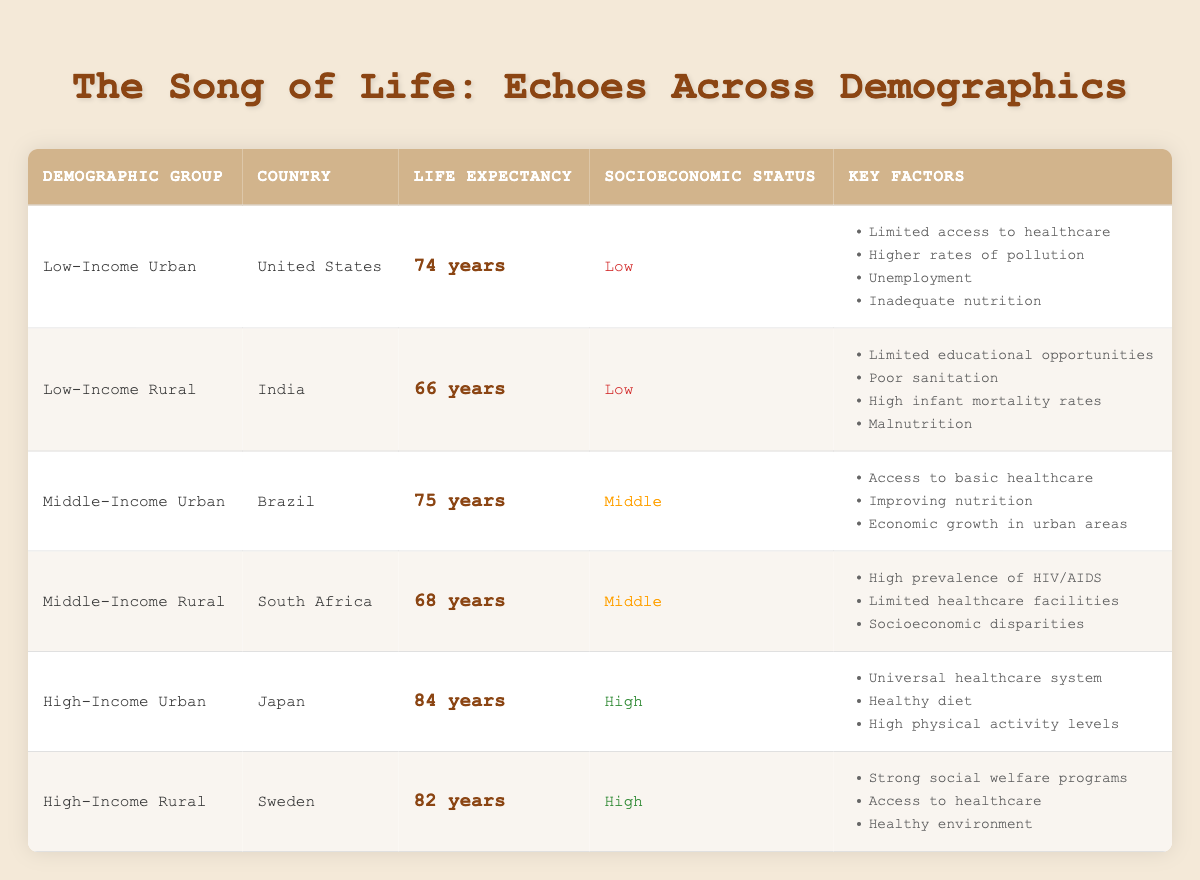What is the average life expectancy for low-income urban residents in the United States? The table shows that the average life expectancy for the low-income urban demographic group in the United States is 74 years.
Answer: 74 years Which demographic group has the lowest life expectancy according to the table? The demographic group with the lowest life expectancy is Low-Income Rural in India, with an average life expectancy of 66 years.
Answer: Low-Income Rural Is the life expectancy for high-income rural residents higher than that of middle-income urban residents? Yes, the life expectancy for high-income rural residents in Sweden is 82 years, while for middle-income urban residents in Brazil, it is 75 years.
Answer: Yes What is the difference in life expectancy between low-income urban and high-income urban groups? The life expectancy for low-income urban residents is 74 years, and for high-income urban residents, it is 84 years. The difference is 84 - 74 = 10 years.
Answer: 10 years Which country has the highest life expectancy and what is it? The highest life expectancy is in Japan, with an average life expectancy of 84 years for the high-income urban demographic.
Answer: Japan, 84 years How many key factors contribute to life expectancy in the Middle-Income Rural group from South Africa? The table lists three key factors that affect life expectancy in the Middle-Income Rural group from South Africa: high prevalence of HIV/AIDS, limited healthcare facilities, and socioeconomic disparities. Therefore, there are three key factors.
Answer: 3 Is adequate nutrition a key factor for life expectancy in low-income urban demographics in the United States? Yes, inadequate nutrition is listed as one of the key factors affecting life expectancy for low-income urban residents.
Answer: Yes If we average the life expectancies of middle-income and low-income groups, what is the result? There are two middle-income groups: 75 years for urban Brazil and 68 years for rural South Africa, averaging to (75 + 68) / 2 = 71.5 years. The low-income groups are 74 years for urban United States and 66 years for rural India, averaging to (74 + 66) / 2 = 70 years. The overall average of these two averages is (71.5 + 70) / 2 = 70.75 years.
Answer: 70.75 years 